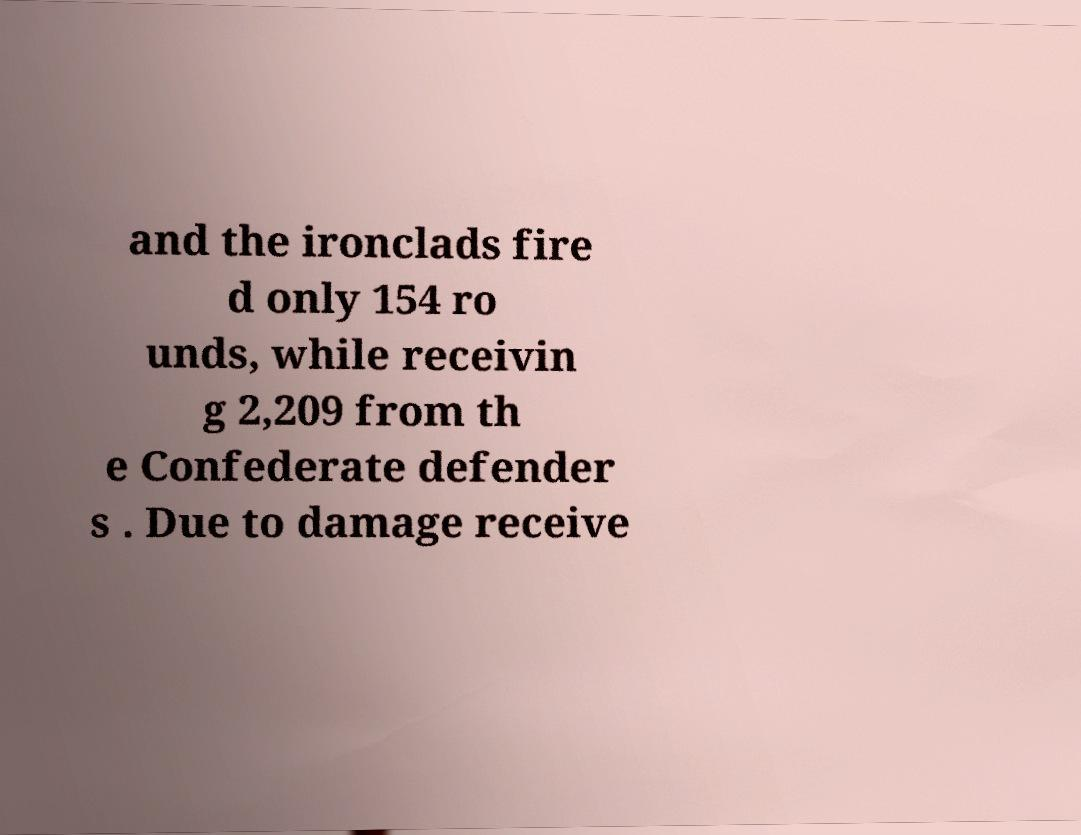Can you accurately transcribe the text from the provided image for me? and the ironclads fire d only 154 ro unds, while receivin g 2,209 from th e Confederate defender s . Due to damage receive 